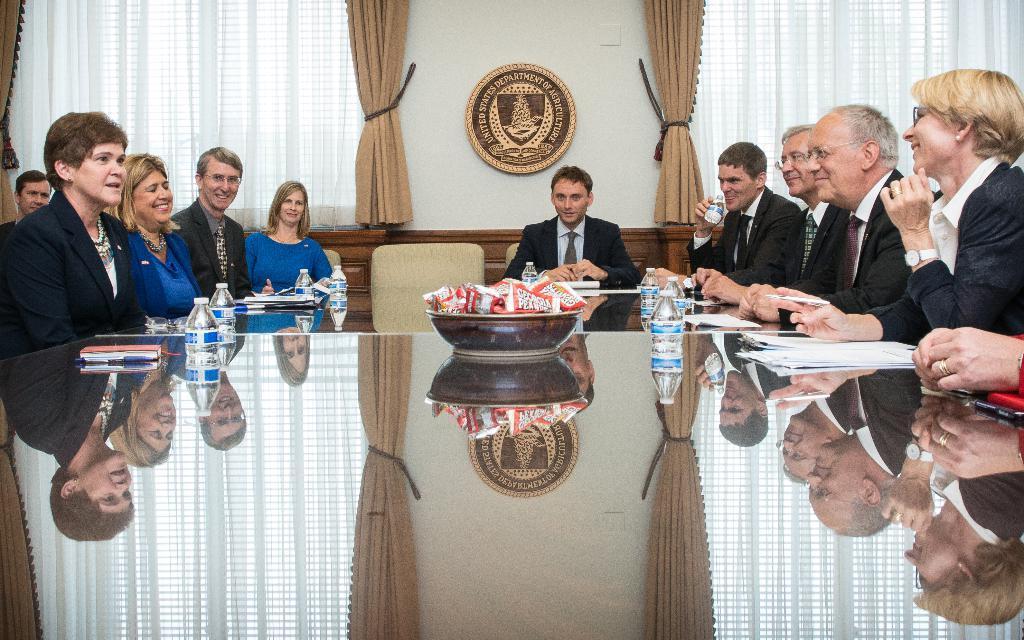Could you give a brief overview of what you see in this image? In this image there is a glass table in the middle and there are few people sitting around it. On the table there are bottles,bowl full of packets,books,pens and a duster. In the middle there is a man who is sitting in the chair. In the background there is a logo attached to the wall and there are two curtains beside it. 